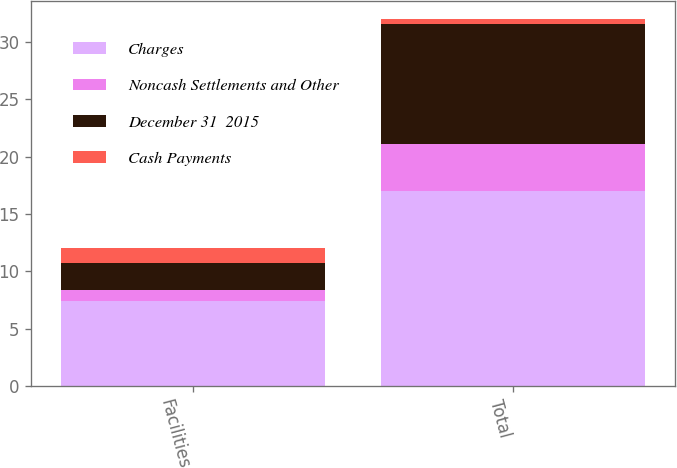<chart> <loc_0><loc_0><loc_500><loc_500><stacked_bar_chart><ecel><fcel>Facilities<fcel>Total<nl><fcel>Charges<fcel>7.4<fcel>17<nl><fcel>Noncash Settlements and Other<fcel>1<fcel>4.1<nl><fcel>December 31  2015<fcel>2.3<fcel>10.5<nl><fcel>Cash Payments<fcel>1.3<fcel>0.4<nl></chart> 